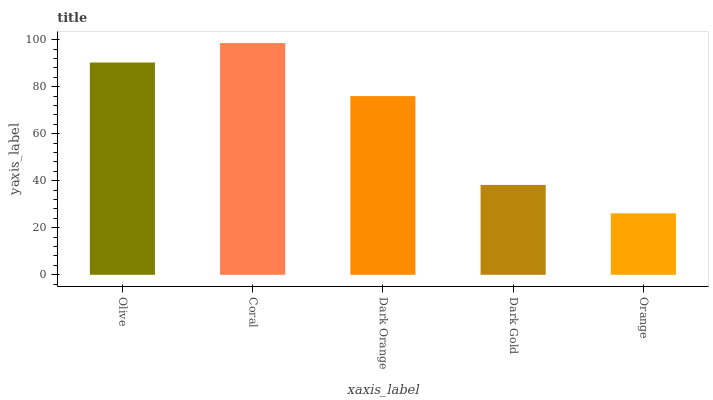Is Orange the minimum?
Answer yes or no. Yes. Is Coral the maximum?
Answer yes or no. Yes. Is Dark Orange the minimum?
Answer yes or no. No. Is Dark Orange the maximum?
Answer yes or no. No. Is Coral greater than Dark Orange?
Answer yes or no. Yes. Is Dark Orange less than Coral?
Answer yes or no. Yes. Is Dark Orange greater than Coral?
Answer yes or no. No. Is Coral less than Dark Orange?
Answer yes or no. No. Is Dark Orange the high median?
Answer yes or no. Yes. Is Dark Orange the low median?
Answer yes or no. Yes. Is Orange the high median?
Answer yes or no. No. Is Coral the low median?
Answer yes or no. No. 